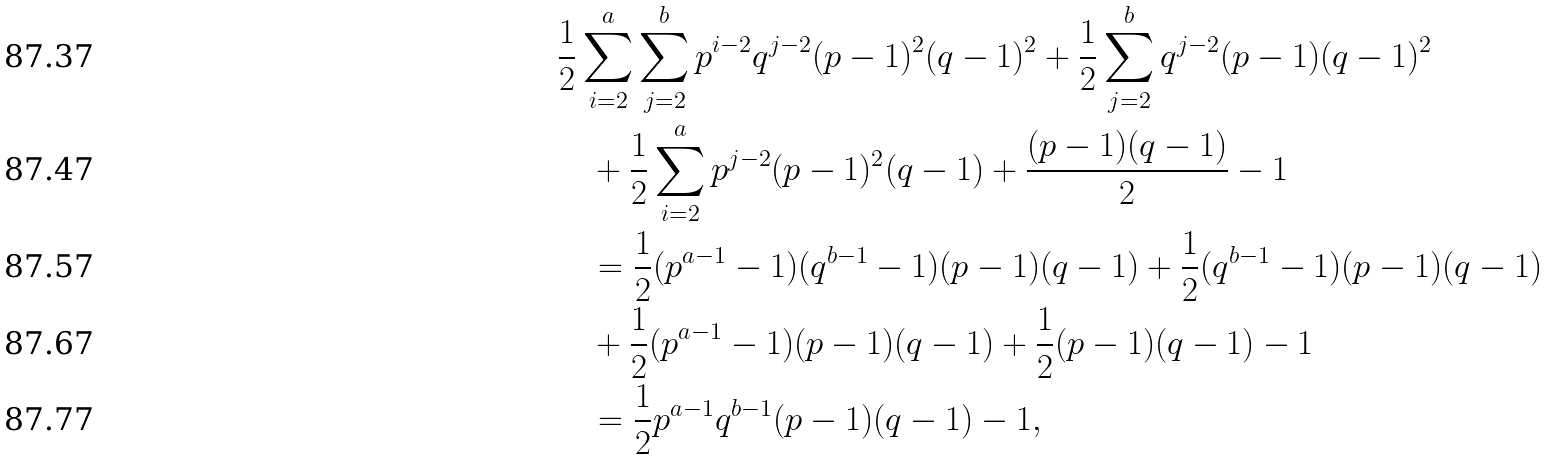Convert formula to latex. <formula><loc_0><loc_0><loc_500><loc_500>& \frac { 1 } { 2 } \sum _ { i = 2 } ^ { a } \sum _ { j = 2 } ^ { b } p ^ { i - 2 } q ^ { j - 2 } ( p - 1 ) ^ { 2 } ( q - 1 ) ^ { 2 } + \frac { 1 } { 2 } \sum _ { j = 2 } ^ { b } q ^ { j - 2 } ( p - 1 ) ( q - 1 ) ^ { 2 } \\ & \quad + \frac { 1 } { 2 } \sum _ { i = 2 } ^ { a } p ^ { j - 2 } ( p - 1 ) ^ { 2 } ( q - 1 ) + \frac { ( p - 1 ) ( q - 1 ) } 2 - 1 \\ & \quad = \frac { 1 } { 2 } ( p ^ { a - 1 } - 1 ) ( q ^ { b - 1 } - 1 ) ( p - 1 ) ( q - 1 ) + \frac { 1 } { 2 } ( q ^ { b - 1 } - 1 ) ( p - 1 ) ( q - 1 ) \\ & \quad + \frac { 1 } { 2 } ( p ^ { a - 1 } - 1 ) ( p - 1 ) ( q - 1 ) + \frac { 1 } { 2 } ( p - 1 ) ( q - 1 ) - 1 \\ & \quad = \frac { 1 } { 2 } p ^ { a - 1 } q ^ { b - 1 } ( p - 1 ) ( q - 1 ) - 1 ,</formula> 